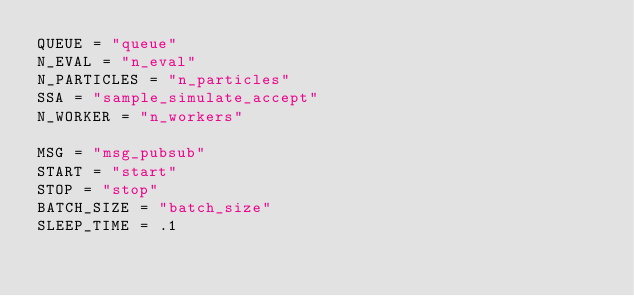<code> <loc_0><loc_0><loc_500><loc_500><_Python_>QUEUE = "queue"
N_EVAL = "n_eval"
N_PARTICLES = "n_particles"
SSA = "sample_simulate_accept"
N_WORKER = "n_workers"

MSG = "msg_pubsub"
START = "start"
STOP = "stop"
BATCH_SIZE = "batch_size"
SLEEP_TIME = .1
</code> 